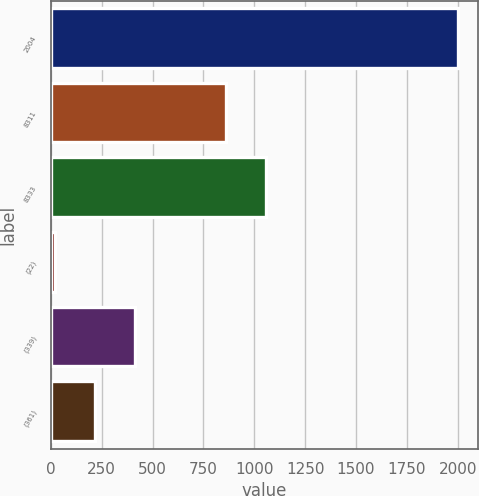<chart> <loc_0><loc_0><loc_500><loc_500><bar_chart><fcel>2004<fcel>8311<fcel>8333<fcel>(22)<fcel>(339)<fcel>(361)<nl><fcel>2002<fcel>860<fcel>1058.3<fcel>19<fcel>415.6<fcel>217.3<nl></chart> 